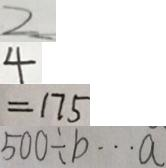Convert formula to latex. <formula><loc_0><loc_0><loc_500><loc_500>2 
 4 
 = 1 7 5 
 5 0 0 \div b \cdots a</formula> 